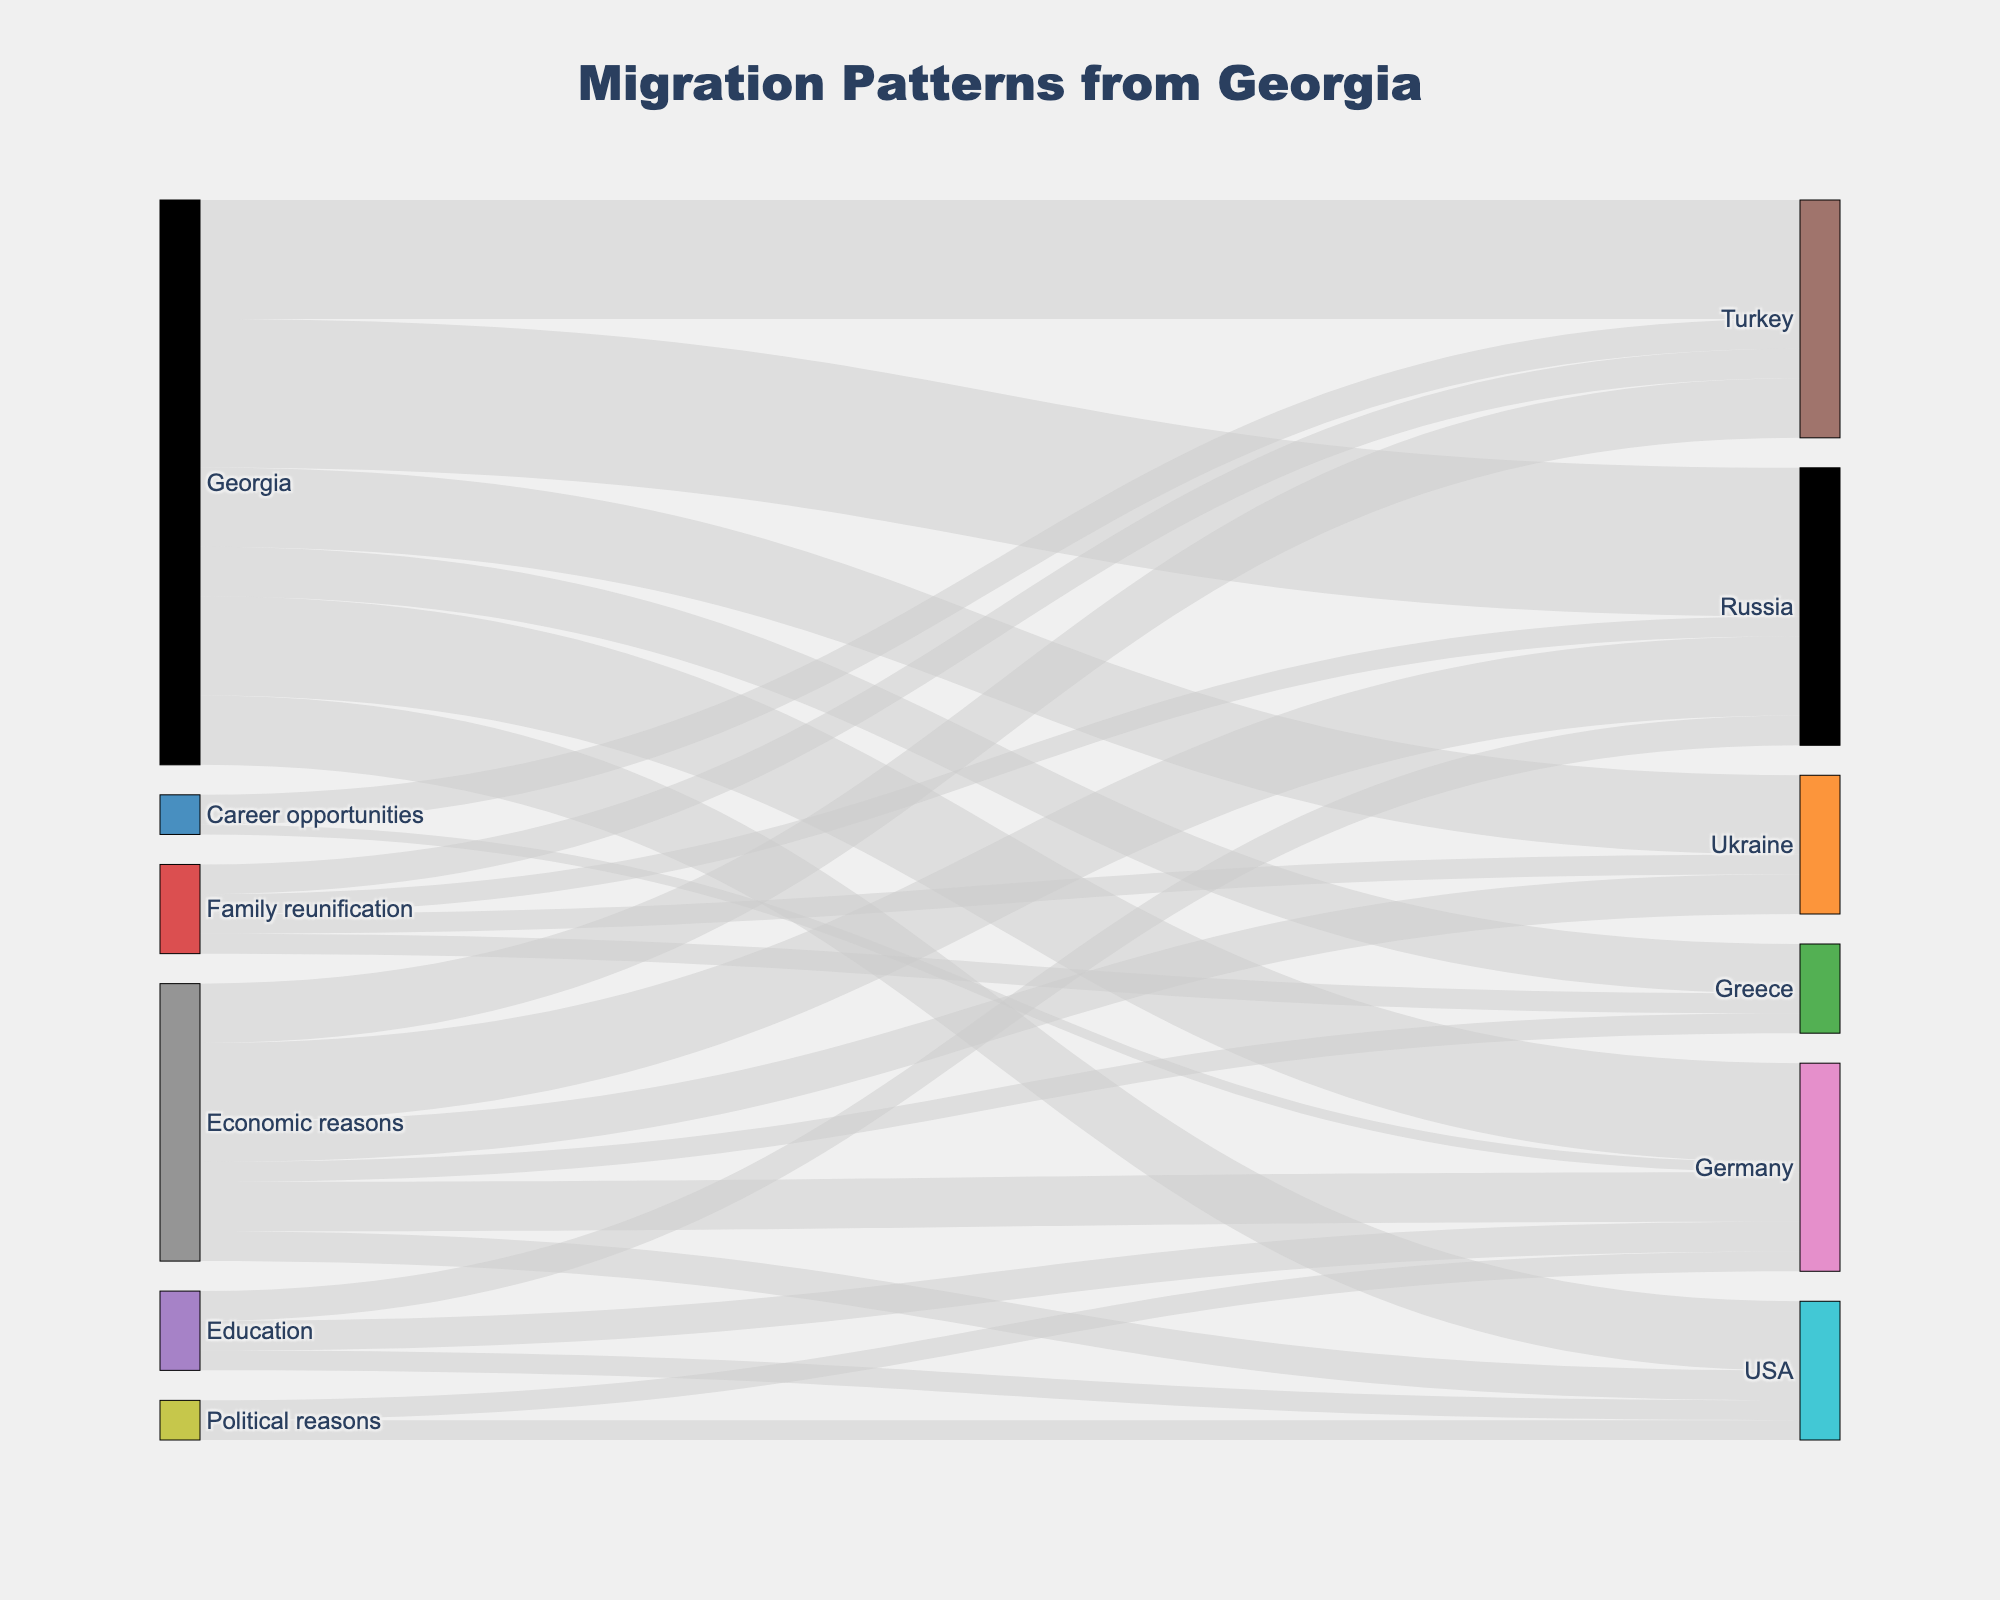What's the main reason people from Georgia migrate to Russia? We examine the flow from Georgia to Russia in the Sankey diagram. The largest flow from Georgia to Russia is linked to economic reasons. Therefore, economic reasons are the primary motivator for migration.
Answer: Economic reasons How many people migrate to Germany for political reasons? The Sankey diagram shows the flow labeled Germany under the node Political reasons. Summing these, we find the migration count is clearly indicated.
Answer: 2000 Which country receives the fewest migrants from Georgia? We compare the target nodes for each country. The label with the smallest value sum under it is Greece (with 5000 individuals), making it the country with the fewest migrants from Georgia.
Answer: Greece What is the total number of people migrating from Georgia for education? To find the total, we summarize all the flows originating from the Education node: Russia (3000), Germany (3000), and USA (2000). Summing these gives 8000.
Answer: 8000 For which reason do equal numbers of people migrate to Ukraine? The Sankey diagram shows we compare the target flows under the label Ukraine. Economic reasons and Family reunification each have 2000 people migrating to Ukraine, thus having equal numbers.
Answer: Economic reasons and Family reunification What is the total number of migrants moving from Georgia to Turkey? We refer to the flows connecting Georgia and Turkey and sum their values: economic reasons (6000), family reunification (3000), and career opportunities (3000). Summing these gives 12000.
Answer: 12000 Which destination has more migrants from Georgia for career opportunities, Turkey or Germany? The Sankey diagram shows the flow value for Turkey is 3000, while for Germany it's 1000. Thus, Turkey has more migrants for career opportunities.
Answer: Turkey Which reasons have exactly the same number of migrants moving from Georgia to the USA? We refer to the USA target node and find both Economic reasons and Political reasons have 2000 migrants each.
Answer: Economic reasons and Political reasons Which reason contributes the most to overall migration from Georgia? By summing up all flows originating from each reason node: Economic reasons (22000), Education (8000), Family reunification (9000), Political reasons (4000), Career opportunities (4000). Economic reasons have the highest total.
Answer: Economic reasons What is the combined total of migrants going from Georgia to the USA and Germany for economic reasons? Summing the flow values under the labels Economic reasons to USA and Germany, which are 3000 and 5000, respectively. Their sum is 8000.
Answer: 8000 